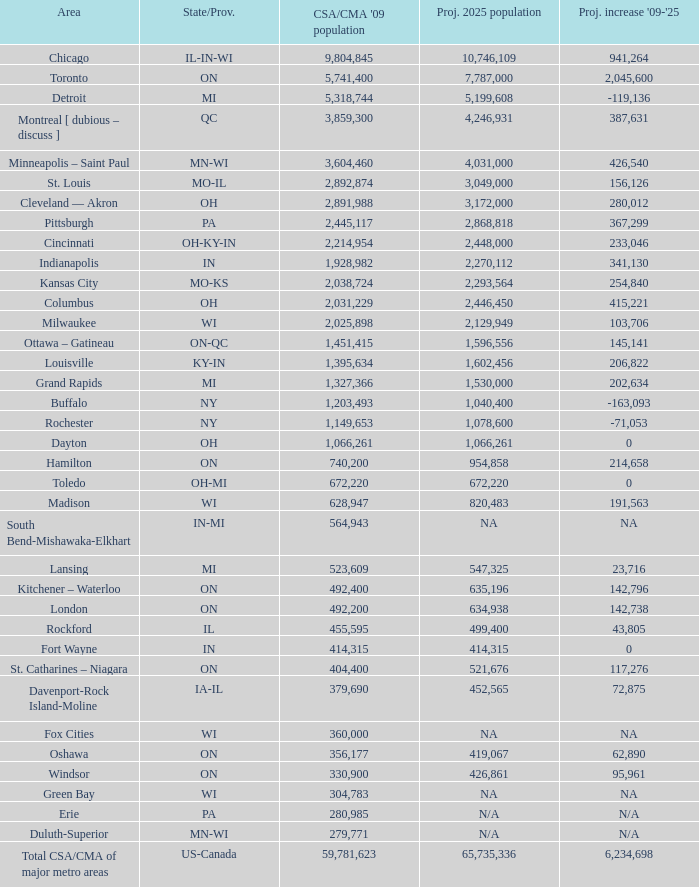What's the CSA/CMA Population in IA-IL? 379690.0. 